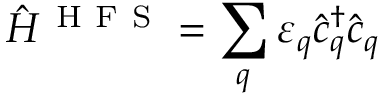Convert formula to latex. <formula><loc_0><loc_0><loc_500><loc_500>{ \hat { H } } ^ { H F S } = \sum _ { q } { \varepsilon } _ { q } { \hat { c } ^ { \dagger } } _ { q } { \hat { c } } _ { q }</formula> 